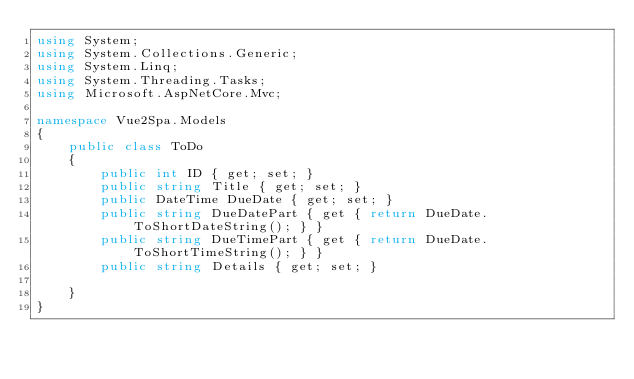<code> <loc_0><loc_0><loc_500><loc_500><_C#_>using System;
using System.Collections.Generic;
using System.Linq;
using System.Threading.Tasks;
using Microsoft.AspNetCore.Mvc;

namespace Vue2Spa.Models
{
    public class ToDo
    {
        public int ID { get; set; }
        public string Title { get; set; }
        public DateTime DueDate { get; set; }
        public string DueDatePart { get { return DueDate.ToShortDateString(); } }
        public string DueTimePart { get { return DueDate.ToShortTimeString(); } }
        public string Details { get; set; }

    }
}
</code> 